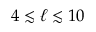<formula> <loc_0><loc_0><loc_500><loc_500>4 \lesssim \ell \lesssim 1 0</formula> 